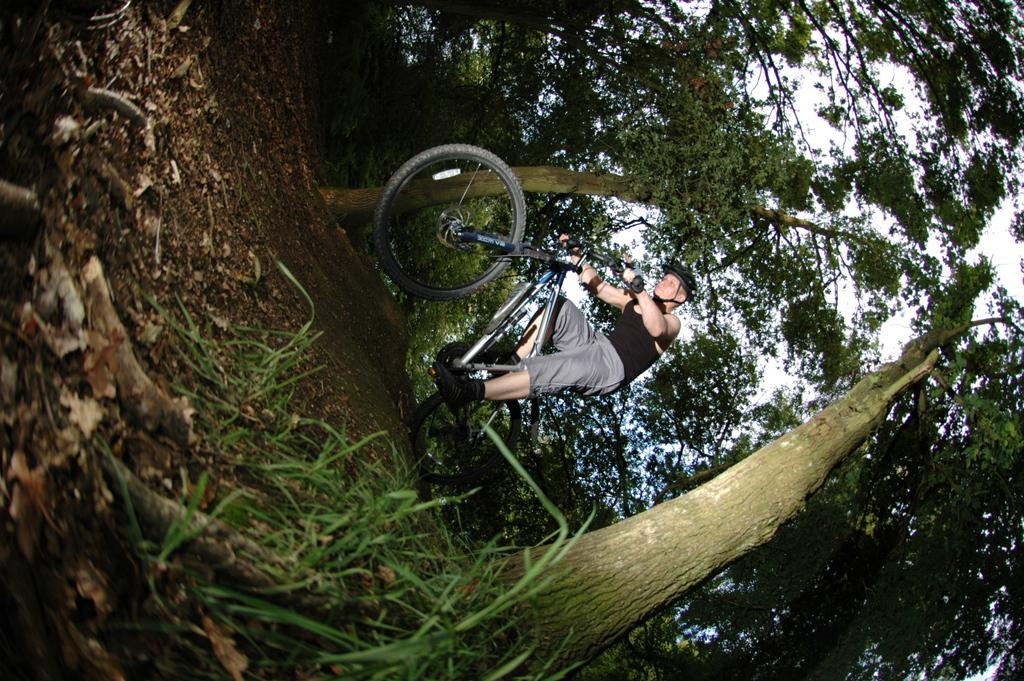Who is in the image? There is a person in the image. What is the person wearing? The person is wearing a helmet. What is the person doing in the image? The person is riding a bicycle. What is the position of the bicycle in the image? The bicycle is on the ground. What can be seen in the background of the image? There is a group of trees and the sky visible in the background of the image. What type of marble is being used by the beggar in the image? There is no beggar or marble present in the image. How does the person in the image make their selection of items? The image does not show the person making any selections, so it cannot be determined from the image. 